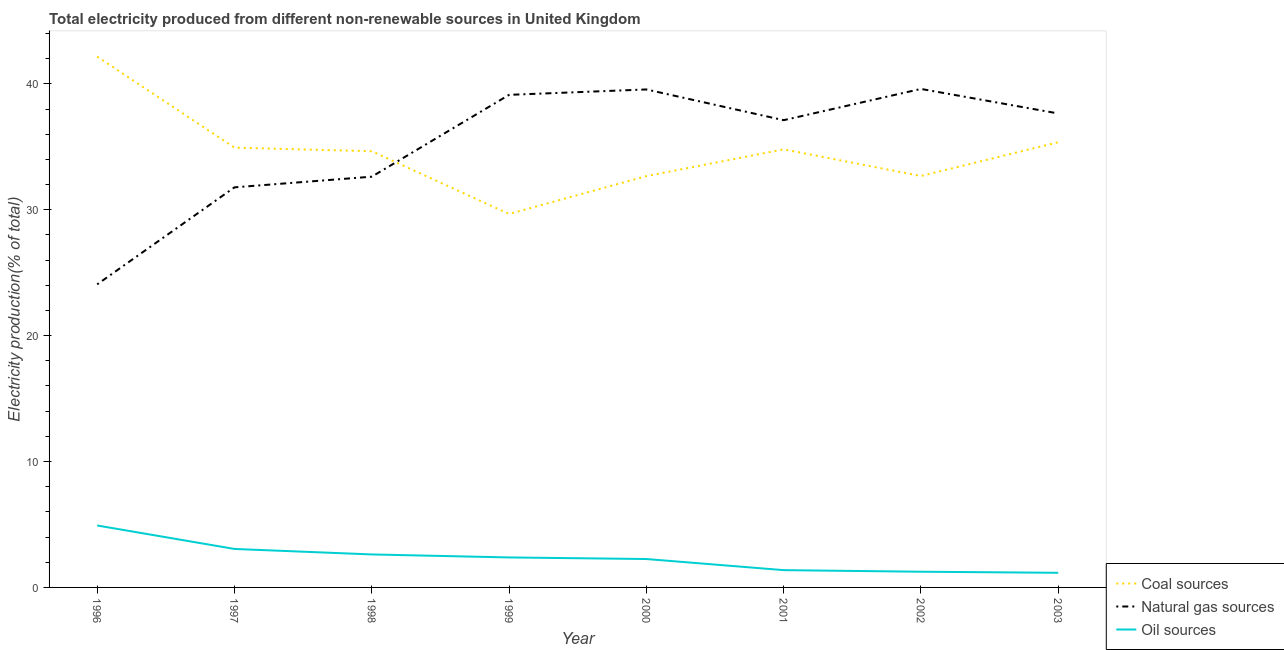Does the line corresponding to percentage of electricity produced by coal intersect with the line corresponding to percentage of electricity produced by oil sources?
Make the answer very short. No. Is the number of lines equal to the number of legend labels?
Give a very brief answer. Yes. What is the percentage of electricity produced by coal in 2003?
Make the answer very short. 35.36. Across all years, what is the maximum percentage of electricity produced by coal?
Ensure brevity in your answer.  42.16. Across all years, what is the minimum percentage of electricity produced by oil sources?
Offer a very short reply. 1.16. In which year was the percentage of electricity produced by oil sources minimum?
Give a very brief answer. 2003. What is the total percentage of electricity produced by natural gas in the graph?
Provide a succinct answer. 281.5. What is the difference between the percentage of electricity produced by natural gas in 2000 and that in 2003?
Provide a succinct answer. 1.91. What is the difference between the percentage of electricity produced by oil sources in 1998 and the percentage of electricity produced by natural gas in 2003?
Provide a short and direct response. -35.03. What is the average percentage of electricity produced by natural gas per year?
Offer a very short reply. 35.19. In the year 1997, what is the difference between the percentage of electricity produced by natural gas and percentage of electricity produced by coal?
Provide a short and direct response. -3.15. What is the ratio of the percentage of electricity produced by coal in 1996 to that in 1997?
Ensure brevity in your answer.  1.21. Is the percentage of electricity produced by coal in 1996 less than that in 2001?
Provide a succinct answer. No. What is the difference between the highest and the second highest percentage of electricity produced by oil sources?
Make the answer very short. 1.86. What is the difference between the highest and the lowest percentage of electricity produced by natural gas?
Your response must be concise. 15.52. In how many years, is the percentage of electricity produced by coal greater than the average percentage of electricity produced by coal taken over all years?
Your response must be concise. 5. Is the sum of the percentage of electricity produced by oil sources in 2000 and 2003 greater than the maximum percentage of electricity produced by natural gas across all years?
Your response must be concise. No. Does the percentage of electricity produced by natural gas monotonically increase over the years?
Offer a terse response. No. Is the percentage of electricity produced by coal strictly greater than the percentage of electricity produced by oil sources over the years?
Your answer should be compact. Yes. How many years are there in the graph?
Offer a terse response. 8. What is the difference between two consecutive major ticks on the Y-axis?
Keep it short and to the point. 10. How many legend labels are there?
Your answer should be very brief. 3. How are the legend labels stacked?
Provide a short and direct response. Vertical. What is the title of the graph?
Your answer should be compact. Total electricity produced from different non-renewable sources in United Kingdom. Does "Ages 50+" appear as one of the legend labels in the graph?
Your answer should be compact. No. What is the label or title of the X-axis?
Your answer should be compact. Year. What is the label or title of the Y-axis?
Your answer should be compact. Electricity production(% of total). What is the Electricity production(% of total) of Coal sources in 1996?
Make the answer very short. 42.16. What is the Electricity production(% of total) in Natural gas sources in 1996?
Your response must be concise. 24.07. What is the Electricity production(% of total) of Oil sources in 1996?
Keep it short and to the point. 4.92. What is the Electricity production(% of total) in Coal sources in 1997?
Your response must be concise. 34.93. What is the Electricity production(% of total) of Natural gas sources in 1997?
Ensure brevity in your answer.  31.78. What is the Electricity production(% of total) of Oil sources in 1997?
Keep it short and to the point. 3.06. What is the Electricity production(% of total) of Coal sources in 1998?
Make the answer very short. 34.65. What is the Electricity production(% of total) of Natural gas sources in 1998?
Give a very brief answer. 32.62. What is the Electricity production(% of total) in Oil sources in 1998?
Your response must be concise. 2.62. What is the Electricity production(% of total) in Coal sources in 1999?
Ensure brevity in your answer.  29.66. What is the Electricity production(% of total) of Natural gas sources in 1999?
Your answer should be very brief. 39.12. What is the Electricity production(% of total) in Oil sources in 1999?
Provide a succinct answer. 2.38. What is the Electricity production(% of total) in Coal sources in 2000?
Ensure brevity in your answer.  32.67. What is the Electricity production(% of total) of Natural gas sources in 2000?
Your answer should be compact. 39.55. What is the Electricity production(% of total) of Oil sources in 2000?
Offer a very short reply. 2.26. What is the Electricity production(% of total) of Coal sources in 2001?
Give a very brief answer. 34.8. What is the Electricity production(% of total) of Natural gas sources in 2001?
Offer a terse response. 37.11. What is the Electricity production(% of total) of Oil sources in 2001?
Give a very brief answer. 1.37. What is the Electricity production(% of total) of Coal sources in 2002?
Ensure brevity in your answer.  32.68. What is the Electricity production(% of total) of Natural gas sources in 2002?
Offer a very short reply. 39.59. What is the Electricity production(% of total) of Oil sources in 2002?
Make the answer very short. 1.25. What is the Electricity production(% of total) in Coal sources in 2003?
Make the answer very short. 35.36. What is the Electricity production(% of total) in Natural gas sources in 2003?
Offer a very short reply. 37.65. What is the Electricity production(% of total) of Oil sources in 2003?
Your response must be concise. 1.16. Across all years, what is the maximum Electricity production(% of total) of Coal sources?
Provide a short and direct response. 42.16. Across all years, what is the maximum Electricity production(% of total) in Natural gas sources?
Provide a succinct answer. 39.59. Across all years, what is the maximum Electricity production(% of total) of Oil sources?
Your answer should be very brief. 4.92. Across all years, what is the minimum Electricity production(% of total) of Coal sources?
Offer a very short reply. 29.66. Across all years, what is the minimum Electricity production(% of total) in Natural gas sources?
Your answer should be compact. 24.07. Across all years, what is the minimum Electricity production(% of total) of Oil sources?
Your answer should be compact. 1.16. What is the total Electricity production(% of total) of Coal sources in the graph?
Give a very brief answer. 276.9. What is the total Electricity production(% of total) of Natural gas sources in the graph?
Keep it short and to the point. 281.5. What is the total Electricity production(% of total) of Oil sources in the graph?
Keep it short and to the point. 19.02. What is the difference between the Electricity production(% of total) of Coal sources in 1996 and that in 1997?
Offer a very short reply. 7.23. What is the difference between the Electricity production(% of total) of Natural gas sources in 1996 and that in 1997?
Your response must be concise. -7.71. What is the difference between the Electricity production(% of total) in Oil sources in 1996 and that in 1997?
Your response must be concise. 1.86. What is the difference between the Electricity production(% of total) of Coal sources in 1996 and that in 1998?
Offer a very short reply. 7.51. What is the difference between the Electricity production(% of total) of Natural gas sources in 1996 and that in 1998?
Your answer should be very brief. -8.55. What is the difference between the Electricity production(% of total) of Oil sources in 1996 and that in 1998?
Your answer should be compact. 2.3. What is the difference between the Electricity production(% of total) of Coal sources in 1996 and that in 1999?
Provide a succinct answer. 12.5. What is the difference between the Electricity production(% of total) of Natural gas sources in 1996 and that in 1999?
Offer a terse response. -15.05. What is the difference between the Electricity production(% of total) in Oil sources in 1996 and that in 1999?
Offer a very short reply. 2.54. What is the difference between the Electricity production(% of total) in Coal sources in 1996 and that in 2000?
Ensure brevity in your answer.  9.49. What is the difference between the Electricity production(% of total) in Natural gas sources in 1996 and that in 2000?
Offer a very short reply. -15.48. What is the difference between the Electricity production(% of total) in Oil sources in 1996 and that in 2000?
Ensure brevity in your answer.  2.66. What is the difference between the Electricity production(% of total) in Coal sources in 1996 and that in 2001?
Ensure brevity in your answer.  7.36. What is the difference between the Electricity production(% of total) of Natural gas sources in 1996 and that in 2001?
Provide a succinct answer. -13.04. What is the difference between the Electricity production(% of total) of Oil sources in 1996 and that in 2001?
Make the answer very short. 3.55. What is the difference between the Electricity production(% of total) in Coal sources in 1996 and that in 2002?
Make the answer very short. 9.48. What is the difference between the Electricity production(% of total) in Natural gas sources in 1996 and that in 2002?
Keep it short and to the point. -15.52. What is the difference between the Electricity production(% of total) of Oil sources in 1996 and that in 2002?
Provide a succinct answer. 3.67. What is the difference between the Electricity production(% of total) in Coal sources in 1996 and that in 2003?
Provide a succinct answer. 6.8. What is the difference between the Electricity production(% of total) of Natural gas sources in 1996 and that in 2003?
Ensure brevity in your answer.  -13.57. What is the difference between the Electricity production(% of total) in Oil sources in 1996 and that in 2003?
Offer a terse response. 3.76. What is the difference between the Electricity production(% of total) in Coal sources in 1997 and that in 1998?
Your response must be concise. 0.28. What is the difference between the Electricity production(% of total) in Natural gas sources in 1997 and that in 1998?
Your answer should be very brief. -0.85. What is the difference between the Electricity production(% of total) in Oil sources in 1997 and that in 1998?
Your response must be concise. 0.44. What is the difference between the Electricity production(% of total) in Coal sources in 1997 and that in 1999?
Ensure brevity in your answer.  5.27. What is the difference between the Electricity production(% of total) of Natural gas sources in 1997 and that in 1999?
Give a very brief answer. -7.35. What is the difference between the Electricity production(% of total) in Oil sources in 1997 and that in 1999?
Offer a very short reply. 0.67. What is the difference between the Electricity production(% of total) in Coal sources in 1997 and that in 2000?
Your answer should be compact. 2.26. What is the difference between the Electricity production(% of total) in Natural gas sources in 1997 and that in 2000?
Provide a short and direct response. -7.78. What is the difference between the Electricity production(% of total) in Oil sources in 1997 and that in 2000?
Keep it short and to the point. 0.8. What is the difference between the Electricity production(% of total) of Coal sources in 1997 and that in 2001?
Give a very brief answer. 0.14. What is the difference between the Electricity production(% of total) in Natural gas sources in 1997 and that in 2001?
Give a very brief answer. -5.33. What is the difference between the Electricity production(% of total) in Oil sources in 1997 and that in 2001?
Offer a terse response. 1.68. What is the difference between the Electricity production(% of total) of Coal sources in 1997 and that in 2002?
Provide a short and direct response. 2.25. What is the difference between the Electricity production(% of total) in Natural gas sources in 1997 and that in 2002?
Your answer should be very brief. -7.82. What is the difference between the Electricity production(% of total) of Oil sources in 1997 and that in 2002?
Your answer should be compact. 1.81. What is the difference between the Electricity production(% of total) in Coal sources in 1997 and that in 2003?
Make the answer very short. -0.43. What is the difference between the Electricity production(% of total) in Natural gas sources in 1997 and that in 2003?
Offer a terse response. -5.87. What is the difference between the Electricity production(% of total) of Oil sources in 1997 and that in 2003?
Your answer should be compact. 1.89. What is the difference between the Electricity production(% of total) in Coal sources in 1998 and that in 1999?
Make the answer very short. 4.98. What is the difference between the Electricity production(% of total) of Natural gas sources in 1998 and that in 1999?
Your answer should be very brief. -6.5. What is the difference between the Electricity production(% of total) in Oil sources in 1998 and that in 1999?
Your answer should be compact. 0.24. What is the difference between the Electricity production(% of total) in Coal sources in 1998 and that in 2000?
Provide a succinct answer. 1.98. What is the difference between the Electricity production(% of total) of Natural gas sources in 1998 and that in 2000?
Ensure brevity in your answer.  -6.93. What is the difference between the Electricity production(% of total) of Oil sources in 1998 and that in 2000?
Make the answer very short. 0.36. What is the difference between the Electricity production(% of total) in Coal sources in 1998 and that in 2001?
Your answer should be very brief. -0.15. What is the difference between the Electricity production(% of total) of Natural gas sources in 1998 and that in 2001?
Offer a terse response. -4.49. What is the difference between the Electricity production(% of total) of Oil sources in 1998 and that in 2001?
Keep it short and to the point. 1.25. What is the difference between the Electricity production(% of total) of Coal sources in 1998 and that in 2002?
Your answer should be compact. 1.97. What is the difference between the Electricity production(% of total) in Natural gas sources in 1998 and that in 2002?
Provide a short and direct response. -6.97. What is the difference between the Electricity production(% of total) in Oil sources in 1998 and that in 2002?
Your answer should be compact. 1.37. What is the difference between the Electricity production(% of total) of Coal sources in 1998 and that in 2003?
Your answer should be very brief. -0.71. What is the difference between the Electricity production(% of total) of Natural gas sources in 1998 and that in 2003?
Your answer should be compact. -5.02. What is the difference between the Electricity production(% of total) of Oil sources in 1998 and that in 2003?
Your answer should be compact. 1.46. What is the difference between the Electricity production(% of total) of Coal sources in 1999 and that in 2000?
Keep it short and to the point. -3.01. What is the difference between the Electricity production(% of total) of Natural gas sources in 1999 and that in 2000?
Keep it short and to the point. -0.43. What is the difference between the Electricity production(% of total) of Oil sources in 1999 and that in 2000?
Provide a short and direct response. 0.13. What is the difference between the Electricity production(% of total) of Coal sources in 1999 and that in 2001?
Provide a succinct answer. -5.13. What is the difference between the Electricity production(% of total) in Natural gas sources in 1999 and that in 2001?
Offer a very short reply. 2.01. What is the difference between the Electricity production(% of total) of Oil sources in 1999 and that in 2001?
Make the answer very short. 1.01. What is the difference between the Electricity production(% of total) in Coal sources in 1999 and that in 2002?
Your response must be concise. -3.02. What is the difference between the Electricity production(% of total) of Natural gas sources in 1999 and that in 2002?
Keep it short and to the point. -0.47. What is the difference between the Electricity production(% of total) in Oil sources in 1999 and that in 2002?
Give a very brief answer. 1.13. What is the difference between the Electricity production(% of total) of Coal sources in 1999 and that in 2003?
Keep it short and to the point. -5.7. What is the difference between the Electricity production(% of total) of Natural gas sources in 1999 and that in 2003?
Your response must be concise. 1.48. What is the difference between the Electricity production(% of total) in Oil sources in 1999 and that in 2003?
Give a very brief answer. 1.22. What is the difference between the Electricity production(% of total) of Coal sources in 2000 and that in 2001?
Your answer should be very brief. -2.13. What is the difference between the Electricity production(% of total) in Natural gas sources in 2000 and that in 2001?
Make the answer very short. 2.44. What is the difference between the Electricity production(% of total) of Oil sources in 2000 and that in 2001?
Your answer should be compact. 0.88. What is the difference between the Electricity production(% of total) in Coal sources in 2000 and that in 2002?
Give a very brief answer. -0.01. What is the difference between the Electricity production(% of total) in Natural gas sources in 2000 and that in 2002?
Give a very brief answer. -0.04. What is the difference between the Electricity production(% of total) of Oil sources in 2000 and that in 2002?
Make the answer very short. 1.01. What is the difference between the Electricity production(% of total) in Coal sources in 2000 and that in 2003?
Provide a short and direct response. -2.69. What is the difference between the Electricity production(% of total) of Natural gas sources in 2000 and that in 2003?
Provide a succinct answer. 1.91. What is the difference between the Electricity production(% of total) of Oil sources in 2000 and that in 2003?
Your response must be concise. 1.09. What is the difference between the Electricity production(% of total) in Coal sources in 2001 and that in 2002?
Your response must be concise. 2.12. What is the difference between the Electricity production(% of total) of Natural gas sources in 2001 and that in 2002?
Ensure brevity in your answer.  -2.48. What is the difference between the Electricity production(% of total) in Oil sources in 2001 and that in 2002?
Keep it short and to the point. 0.13. What is the difference between the Electricity production(% of total) in Coal sources in 2001 and that in 2003?
Provide a short and direct response. -0.56. What is the difference between the Electricity production(% of total) of Natural gas sources in 2001 and that in 2003?
Your answer should be compact. -0.53. What is the difference between the Electricity production(% of total) in Oil sources in 2001 and that in 2003?
Make the answer very short. 0.21. What is the difference between the Electricity production(% of total) in Coal sources in 2002 and that in 2003?
Give a very brief answer. -2.68. What is the difference between the Electricity production(% of total) in Natural gas sources in 2002 and that in 2003?
Provide a succinct answer. 1.95. What is the difference between the Electricity production(% of total) of Oil sources in 2002 and that in 2003?
Your response must be concise. 0.09. What is the difference between the Electricity production(% of total) of Coal sources in 1996 and the Electricity production(% of total) of Natural gas sources in 1997?
Your response must be concise. 10.38. What is the difference between the Electricity production(% of total) in Coal sources in 1996 and the Electricity production(% of total) in Oil sources in 1997?
Your answer should be very brief. 39.1. What is the difference between the Electricity production(% of total) of Natural gas sources in 1996 and the Electricity production(% of total) of Oil sources in 1997?
Make the answer very short. 21.02. What is the difference between the Electricity production(% of total) in Coal sources in 1996 and the Electricity production(% of total) in Natural gas sources in 1998?
Your answer should be compact. 9.54. What is the difference between the Electricity production(% of total) of Coal sources in 1996 and the Electricity production(% of total) of Oil sources in 1998?
Give a very brief answer. 39.54. What is the difference between the Electricity production(% of total) in Natural gas sources in 1996 and the Electricity production(% of total) in Oil sources in 1998?
Provide a short and direct response. 21.45. What is the difference between the Electricity production(% of total) of Coal sources in 1996 and the Electricity production(% of total) of Natural gas sources in 1999?
Give a very brief answer. 3.04. What is the difference between the Electricity production(% of total) in Coal sources in 1996 and the Electricity production(% of total) in Oil sources in 1999?
Offer a very short reply. 39.78. What is the difference between the Electricity production(% of total) of Natural gas sources in 1996 and the Electricity production(% of total) of Oil sources in 1999?
Offer a terse response. 21.69. What is the difference between the Electricity production(% of total) of Coal sources in 1996 and the Electricity production(% of total) of Natural gas sources in 2000?
Keep it short and to the point. 2.61. What is the difference between the Electricity production(% of total) in Coal sources in 1996 and the Electricity production(% of total) in Oil sources in 2000?
Offer a very short reply. 39.9. What is the difference between the Electricity production(% of total) in Natural gas sources in 1996 and the Electricity production(% of total) in Oil sources in 2000?
Offer a very short reply. 21.82. What is the difference between the Electricity production(% of total) of Coal sources in 1996 and the Electricity production(% of total) of Natural gas sources in 2001?
Your answer should be compact. 5.05. What is the difference between the Electricity production(% of total) in Coal sources in 1996 and the Electricity production(% of total) in Oil sources in 2001?
Your response must be concise. 40.79. What is the difference between the Electricity production(% of total) of Natural gas sources in 1996 and the Electricity production(% of total) of Oil sources in 2001?
Keep it short and to the point. 22.7. What is the difference between the Electricity production(% of total) of Coal sources in 1996 and the Electricity production(% of total) of Natural gas sources in 2002?
Offer a terse response. 2.57. What is the difference between the Electricity production(% of total) in Coal sources in 1996 and the Electricity production(% of total) in Oil sources in 2002?
Your answer should be very brief. 40.91. What is the difference between the Electricity production(% of total) of Natural gas sources in 1996 and the Electricity production(% of total) of Oil sources in 2002?
Your answer should be very brief. 22.82. What is the difference between the Electricity production(% of total) of Coal sources in 1996 and the Electricity production(% of total) of Natural gas sources in 2003?
Your answer should be very brief. 4.51. What is the difference between the Electricity production(% of total) of Coal sources in 1996 and the Electricity production(% of total) of Oil sources in 2003?
Offer a very short reply. 41. What is the difference between the Electricity production(% of total) in Natural gas sources in 1996 and the Electricity production(% of total) in Oil sources in 2003?
Keep it short and to the point. 22.91. What is the difference between the Electricity production(% of total) in Coal sources in 1997 and the Electricity production(% of total) in Natural gas sources in 1998?
Offer a terse response. 2.31. What is the difference between the Electricity production(% of total) in Coal sources in 1997 and the Electricity production(% of total) in Oil sources in 1998?
Ensure brevity in your answer.  32.31. What is the difference between the Electricity production(% of total) in Natural gas sources in 1997 and the Electricity production(% of total) in Oil sources in 1998?
Offer a very short reply. 29.16. What is the difference between the Electricity production(% of total) in Coal sources in 1997 and the Electricity production(% of total) in Natural gas sources in 1999?
Your answer should be compact. -4.19. What is the difference between the Electricity production(% of total) in Coal sources in 1997 and the Electricity production(% of total) in Oil sources in 1999?
Your answer should be compact. 32.55. What is the difference between the Electricity production(% of total) of Natural gas sources in 1997 and the Electricity production(% of total) of Oil sources in 1999?
Give a very brief answer. 29.4. What is the difference between the Electricity production(% of total) of Coal sources in 1997 and the Electricity production(% of total) of Natural gas sources in 2000?
Provide a succinct answer. -4.62. What is the difference between the Electricity production(% of total) of Coal sources in 1997 and the Electricity production(% of total) of Oil sources in 2000?
Keep it short and to the point. 32.68. What is the difference between the Electricity production(% of total) in Natural gas sources in 1997 and the Electricity production(% of total) in Oil sources in 2000?
Your response must be concise. 29.52. What is the difference between the Electricity production(% of total) of Coal sources in 1997 and the Electricity production(% of total) of Natural gas sources in 2001?
Your response must be concise. -2.18. What is the difference between the Electricity production(% of total) of Coal sources in 1997 and the Electricity production(% of total) of Oil sources in 2001?
Ensure brevity in your answer.  33.56. What is the difference between the Electricity production(% of total) of Natural gas sources in 1997 and the Electricity production(% of total) of Oil sources in 2001?
Ensure brevity in your answer.  30.4. What is the difference between the Electricity production(% of total) in Coal sources in 1997 and the Electricity production(% of total) in Natural gas sources in 2002?
Offer a terse response. -4.66. What is the difference between the Electricity production(% of total) in Coal sources in 1997 and the Electricity production(% of total) in Oil sources in 2002?
Your answer should be compact. 33.68. What is the difference between the Electricity production(% of total) in Natural gas sources in 1997 and the Electricity production(% of total) in Oil sources in 2002?
Provide a short and direct response. 30.53. What is the difference between the Electricity production(% of total) of Coal sources in 1997 and the Electricity production(% of total) of Natural gas sources in 2003?
Give a very brief answer. -2.71. What is the difference between the Electricity production(% of total) in Coal sources in 1997 and the Electricity production(% of total) in Oil sources in 2003?
Your response must be concise. 33.77. What is the difference between the Electricity production(% of total) in Natural gas sources in 1997 and the Electricity production(% of total) in Oil sources in 2003?
Your answer should be compact. 30.62. What is the difference between the Electricity production(% of total) of Coal sources in 1998 and the Electricity production(% of total) of Natural gas sources in 1999?
Make the answer very short. -4.48. What is the difference between the Electricity production(% of total) in Coal sources in 1998 and the Electricity production(% of total) in Oil sources in 1999?
Keep it short and to the point. 32.26. What is the difference between the Electricity production(% of total) of Natural gas sources in 1998 and the Electricity production(% of total) of Oil sources in 1999?
Give a very brief answer. 30.24. What is the difference between the Electricity production(% of total) in Coal sources in 1998 and the Electricity production(% of total) in Natural gas sources in 2000?
Make the answer very short. -4.91. What is the difference between the Electricity production(% of total) in Coal sources in 1998 and the Electricity production(% of total) in Oil sources in 2000?
Offer a very short reply. 32.39. What is the difference between the Electricity production(% of total) in Natural gas sources in 1998 and the Electricity production(% of total) in Oil sources in 2000?
Your answer should be very brief. 30.37. What is the difference between the Electricity production(% of total) in Coal sources in 1998 and the Electricity production(% of total) in Natural gas sources in 2001?
Provide a short and direct response. -2.47. What is the difference between the Electricity production(% of total) in Coal sources in 1998 and the Electricity production(% of total) in Oil sources in 2001?
Your response must be concise. 33.27. What is the difference between the Electricity production(% of total) of Natural gas sources in 1998 and the Electricity production(% of total) of Oil sources in 2001?
Offer a very short reply. 31.25. What is the difference between the Electricity production(% of total) in Coal sources in 1998 and the Electricity production(% of total) in Natural gas sources in 2002?
Your answer should be very brief. -4.95. What is the difference between the Electricity production(% of total) in Coal sources in 1998 and the Electricity production(% of total) in Oil sources in 2002?
Your response must be concise. 33.4. What is the difference between the Electricity production(% of total) of Natural gas sources in 1998 and the Electricity production(% of total) of Oil sources in 2002?
Offer a very short reply. 31.38. What is the difference between the Electricity production(% of total) in Coal sources in 1998 and the Electricity production(% of total) in Natural gas sources in 2003?
Provide a short and direct response. -3. What is the difference between the Electricity production(% of total) in Coal sources in 1998 and the Electricity production(% of total) in Oil sources in 2003?
Keep it short and to the point. 33.48. What is the difference between the Electricity production(% of total) of Natural gas sources in 1998 and the Electricity production(% of total) of Oil sources in 2003?
Your answer should be very brief. 31.46. What is the difference between the Electricity production(% of total) in Coal sources in 1999 and the Electricity production(% of total) in Natural gas sources in 2000?
Offer a very short reply. -9.89. What is the difference between the Electricity production(% of total) in Coal sources in 1999 and the Electricity production(% of total) in Oil sources in 2000?
Provide a short and direct response. 27.41. What is the difference between the Electricity production(% of total) of Natural gas sources in 1999 and the Electricity production(% of total) of Oil sources in 2000?
Your answer should be compact. 36.87. What is the difference between the Electricity production(% of total) in Coal sources in 1999 and the Electricity production(% of total) in Natural gas sources in 2001?
Provide a succinct answer. -7.45. What is the difference between the Electricity production(% of total) in Coal sources in 1999 and the Electricity production(% of total) in Oil sources in 2001?
Keep it short and to the point. 28.29. What is the difference between the Electricity production(% of total) in Natural gas sources in 1999 and the Electricity production(% of total) in Oil sources in 2001?
Make the answer very short. 37.75. What is the difference between the Electricity production(% of total) in Coal sources in 1999 and the Electricity production(% of total) in Natural gas sources in 2002?
Provide a short and direct response. -9.93. What is the difference between the Electricity production(% of total) in Coal sources in 1999 and the Electricity production(% of total) in Oil sources in 2002?
Your answer should be very brief. 28.41. What is the difference between the Electricity production(% of total) of Natural gas sources in 1999 and the Electricity production(% of total) of Oil sources in 2002?
Your answer should be compact. 37.88. What is the difference between the Electricity production(% of total) of Coal sources in 1999 and the Electricity production(% of total) of Natural gas sources in 2003?
Offer a very short reply. -7.98. What is the difference between the Electricity production(% of total) of Coal sources in 1999 and the Electricity production(% of total) of Oil sources in 2003?
Your response must be concise. 28.5. What is the difference between the Electricity production(% of total) of Natural gas sources in 1999 and the Electricity production(% of total) of Oil sources in 2003?
Your answer should be compact. 37.96. What is the difference between the Electricity production(% of total) in Coal sources in 2000 and the Electricity production(% of total) in Natural gas sources in 2001?
Your answer should be very brief. -4.44. What is the difference between the Electricity production(% of total) in Coal sources in 2000 and the Electricity production(% of total) in Oil sources in 2001?
Offer a terse response. 31.29. What is the difference between the Electricity production(% of total) in Natural gas sources in 2000 and the Electricity production(% of total) in Oil sources in 2001?
Offer a terse response. 38.18. What is the difference between the Electricity production(% of total) of Coal sources in 2000 and the Electricity production(% of total) of Natural gas sources in 2002?
Make the answer very short. -6.93. What is the difference between the Electricity production(% of total) of Coal sources in 2000 and the Electricity production(% of total) of Oil sources in 2002?
Make the answer very short. 31.42. What is the difference between the Electricity production(% of total) in Natural gas sources in 2000 and the Electricity production(% of total) in Oil sources in 2002?
Your answer should be very brief. 38.31. What is the difference between the Electricity production(% of total) in Coal sources in 2000 and the Electricity production(% of total) in Natural gas sources in 2003?
Keep it short and to the point. -4.98. What is the difference between the Electricity production(% of total) in Coal sources in 2000 and the Electricity production(% of total) in Oil sources in 2003?
Give a very brief answer. 31.51. What is the difference between the Electricity production(% of total) of Natural gas sources in 2000 and the Electricity production(% of total) of Oil sources in 2003?
Keep it short and to the point. 38.39. What is the difference between the Electricity production(% of total) in Coal sources in 2001 and the Electricity production(% of total) in Natural gas sources in 2002?
Offer a very short reply. -4.8. What is the difference between the Electricity production(% of total) in Coal sources in 2001 and the Electricity production(% of total) in Oil sources in 2002?
Ensure brevity in your answer.  33.55. What is the difference between the Electricity production(% of total) in Natural gas sources in 2001 and the Electricity production(% of total) in Oil sources in 2002?
Give a very brief answer. 35.86. What is the difference between the Electricity production(% of total) in Coal sources in 2001 and the Electricity production(% of total) in Natural gas sources in 2003?
Offer a very short reply. -2.85. What is the difference between the Electricity production(% of total) in Coal sources in 2001 and the Electricity production(% of total) in Oil sources in 2003?
Provide a short and direct response. 33.63. What is the difference between the Electricity production(% of total) in Natural gas sources in 2001 and the Electricity production(% of total) in Oil sources in 2003?
Your answer should be very brief. 35.95. What is the difference between the Electricity production(% of total) of Coal sources in 2002 and the Electricity production(% of total) of Natural gas sources in 2003?
Keep it short and to the point. -4.97. What is the difference between the Electricity production(% of total) of Coal sources in 2002 and the Electricity production(% of total) of Oil sources in 2003?
Your answer should be very brief. 31.52. What is the difference between the Electricity production(% of total) in Natural gas sources in 2002 and the Electricity production(% of total) in Oil sources in 2003?
Give a very brief answer. 38.43. What is the average Electricity production(% of total) of Coal sources per year?
Offer a terse response. 34.61. What is the average Electricity production(% of total) of Natural gas sources per year?
Provide a short and direct response. 35.19. What is the average Electricity production(% of total) of Oil sources per year?
Your answer should be very brief. 2.38. In the year 1996, what is the difference between the Electricity production(% of total) in Coal sources and Electricity production(% of total) in Natural gas sources?
Offer a very short reply. 18.09. In the year 1996, what is the difference between the Electricity production(% of total) of Coal sources and Electricity production(% of total) of Oil sources?
Make the answer very short. 37.24. In the year 1996, what is the difference between the Electricity production(% of total) in Natural gas sources and Electricity production(% of total) in Oil sources?
Offer a very short reply. 19.15. In the year 1997, what is the difference between the Electricity production(% of total) of Coal sources and Electricity production(% of total) of Natural gas sources?
Your response must be concise. 3.15. In the year 1997, what is the difference between the Electricity production(% of total) in Coal sources and Electricity production(% of total) in Oil sources?
Keep it short and to the point. 31.88. In the year 1997, what is the difference between the Electricity production(% of total) of Natural gas sources and Electricity production(% of total) of Oil sources?
Make the answer very short. 28.72. In the year 1998, what is the difference between the Electricity production(% of total) of Coal sources and Electricity production(% of total) of Natural gas sources?
Offer a terse response. 2.02. In the year 1998, what is the difference between the Electricity production(% of total) in Coal sources and Electricity production(% of total) in Oil sources?
Make the answer very short. 32.03. In the year 1998, what is the difference between the Electricity production(% of total) of Natural gas sources and Electricity production(% of total) of Oil sources?
Your response must be concise. 30. In the year 1999, what is the difference between the Electricity production(% of total) of Coal sources and Electricity production(% of total) of Natural gas sources?
Your response must be concise. -9.46. In the year 1999, what is the difference between the Electricity production(% of total) of Coal sources and Electricity production(% of total) of Oil sources?
Offer a very short reply. 27.28. In the year 1999, what is the difference between the Electricity production(% of total) in Natural gas sources and Electricity production(% of total) in Oil sources?
Offer a terse response. 36.74. In the year 2000, what is the difference between the Electricity production(% of total) of Coal sources and Electricity production(% of total) of Natural gas sources?
Make the answer very short. -6.89. In the year 2000, what is the difference between the Electricity production(% of total) in Coal sources and Electricity production(% of total) in Oil sources?
Provide a succinct answer. 30.41. In the year 2000, what is the difference between the Electricity production(% of total) of Natural gas sources and Electricity production(% of total) of Oil sources?
Keep it short and to the point. 37.3. In the year 2001, what is the difference between the Electricity production(% of total) in Coal sources and Electricity production(% of total) in Natural gas sources?
Ensure brevity in your answer.  -2.32. In the year 2001, what is the difference between the Electricity production(% of total) of Coal sources and Electricity production(% of total) of Oil sources?
Your answer should be compact. 33.42. In the year 2001, what is the difference between the Electricity production(% of total) in Natural gas sources and Electricity production(% of total) in Oil sources?
Offer a terse response. 35.74. In the year 2002, what is the difference between the Electricity production(% of total) of Coal sources and Electricity production(% of total) of Natural gas sources?
Your answer should be very brief. -6.92. In the year 2002, what is the difference between the Electricity production(% of total) of Coal sources and Electricity production(% of total) of Oil sources?
Give a very brief answer. 31.43. In the year 2002, what is the difference between the Electricity production(% of total) in Natural gas sources and Electricity production(% of total) in Oil sources?
Give a very brief answer. 38.35. In the year 2003, what is the difference between the Electricity production(% of total) in Coal sources and Electricity production(% of total) in Natural gas sources?
Keep it short and to the point. -2.29. In the year 2003, what is the difference between the Electricity production(% of total) of Coal sources and Electricity production(% of total) of Oil sources?
Provide a succinct answer. 34.2. In the year 2003, what is the difference between the Electricity production(% of total) of Natural gas sources and Electricity production(% of total) of Oil sources?
Your answer should be compact. 36.48. What is the ratio of the Electricity production(% of total) in Coal sources in 1996 to that in 1997?
Your answer should be compact. 1.21. What is the ratio of the Electricity production(% of total) of Natural gas sources in 1996 to that in 1997?
Make the answer very short. 0.76. What is the ratio of the Electricity production(% of total) in Oil sources in 1996 to that in 1997?
Give a very brief answer. 1.61. What is the ratio of the Electricity production(% of total) of Coal sources in 1996 to that in 1998?
Offer a terse response. 1.22. What is the ratio of the Electricity production(% of total) of Natural gas sources in 1996 to that in 1998?
Provide a short and direct response. 0.74. What is the ratio of the Electricity production(% of total) in Oil sources in 1996 to that in 1998?
Offer a very short reply. 1.88. What is the ratio of the Electricity production(% of total) of Coal sources in 1996 to that in 1999?
Provide a succinct answer. 1.42. What is the ratio of the Electricity production(% of total) in Natural gas sources in 1996 to that in 1999?
Provide a short and direct response. 0.62. What is the ratio of the Electricity production(% of total) in Oil sources in 1996 to that in 1999?
Offer a terse response. 2.07. What is the ratio of the Electricity production(% of total) in Coal sources in 1996 to that in 2000?
Your answer should be compact. 1.29. What is the ratio of the Electricity production(% of total) in Natural gas sources in 1996 to that in 2000?
Offer a very short reply. 0.61. What is the ratio of the Electricity production(% of total) of Oil sources in 1996 to that in 2000?
Offer a very short reply. 2.18. What is the ratio of the Electricity production(% of total) of Coal sources in 1996 to that in 2001?
Offer a terse response. 1.21. What is the ratio of the Electricity production(% of total) of Natural gas sources in 1996 to that in 2001?
Ensure brevity in your answer.  0.65. What is the ratio of the Electricity production(% of total) in Oil sources in 1996 to that in 2001?
Make the answer very short. 3.58. What is the ratio of the Electricity production(% of total) in Coal sources in 1996 to that in 2002?
Your answer should be compact. 1.29. What is the ratio of the Electricity production(% of total) of Natural gas sources in 1996 to that in 2002?
Your answer should be compact. 0.61. What is the ratio of the Electricity production(% of total) in Oil sources in 1996 to that in 2002?
Provide a succinct answer. 3.94. What is the ratio of the Electricity production(% of total) of Coal sources in 1996 to that in 2003?
Your response must be concise. 1.19. What is the ratio of the Electricity production(% of total) in Natural gas sources in 1996 to that in 2003?
Your response must be concise. 0.64. What is the ratio of the Electricity production(% of total) in Oil sources in 1996 to that in 2003?
Offer a very short reply. 4.24. What is the ratio of the Electricity production(% of total) of Coal sources in 1997 to that in 1998?
Your answer should be very brief. 1.01. What is the ratio of the Electricity production(% of total) in Natural gas sources in 1997 to that in 1998?
Your response must be concise. 0.97. What is the ratio of the Electricity production(% of total) in Oil sources in 1997 to that in 1998?
Your answer should be very brief. 1.17. What is the ratio of the Electricity production(% of total) in Coal sources in 1997 to that in 1999?
Provide a short and direct response. 1.18. What is the ratio of the Electricity production(% of total) of Natural gas sources in 1997 to that in 1999?
Provide a short and direct response. 0.81. What is the ratio of the Electricity production(% of total) in Oil sources in 1997 to that in 1999?
Provide a short and direct response. 1.28. What is the ratio of the Electricity production(% of total) in Coal sources in 1997 to that in 2000?
Offer a very short reply. 1.07. What is the ratio of the Electricity production(% of total) of Natural gas sources in 1997 to that in 2000?
Make the answer very short. 0.8. What is the ratio of the Electricity production(% of total) of Oil sources in 1997 to that in 2000?
Ensure brevity in your answer.  1.35. What is the ratio of the Electricity production(% of total) in Natural gas sources in 1997 to that in 2001?
Offer a very short reply. 0.86. What is the ratio of the Electricity production(% of total) of Oil sources in 1997 to that in 2001?
Keep it short and to the point. 2.22. What is the ratio of the Electricity production(% of total) of Coal sources in 1997 to that in 2002?
Give a very brief answer. 1.07. What is the ratio of the Electricity production(% of total) of Natural gas sources in 1997 to that in 2002?
Keep it short and to the point. 0.8. What is the ratio of the Electricity production(% of total) in Oil sources in 1997 to that in 2002?
Provide a succinct answer. 2.45. What is the ratio of the Electricity production(% of total) in Coal sources in 1997 to that in 2003?
Offer a terse response. 0.99. What is the ratio of the Electricity production(% of total) in Natural gas sources in 1997 to that in 2003?
Keep it short and to the point. 0.84. What is the ratio of the Electricity production(% of total) in Oil sources in 1997 to that in 2003?
Keep it short and to the point. 2.63. What is the ratio of the Electricity production(% of total) of Coal sources in 1998 to that in 1999?
Ensure brevity in your answer.  1.17. What is the ratio of the Electricity production(% of total) of Natural gas sources in 1998 to that in 1999?
Your answer should be compact. 0.83. What is the ratio of the Electricity production(% of total) of Coal sources in 1998 to that in 2000?
Make the answer very short. 1.06. What is the ratio of the Electricity production(% of total) in Natural gas sources in 1998 to that in 2000?
Your answer should be very brief. 0.82. What is the ratio of the Electricity production(% of total) of Oil sources in 1998 to that in 2000?
Ensure brevity in your answer.  1.16. What is the ratio of the Electricity production(% of total) of Coal sources in 1998 to that in 2001?
Your answer should be very brief. 1. What is the ratio of the Electricity production(% of total) of Natural gas sources in 1998 to that in 2001?
Your answer should be compact. 0.88. What is the ratio of the Electricity production(% of total) in Oil sources in 1998 to that in 2001?
Make the answer very short. 1.91. What is the ratio of the Electricity production(% of total) of Coal sources in 1998 to that in 2002?
Your answer should be compact. 1.06. What is the ratio of the Electricity production(% of total) of Natural gas sources in 1998 to that in 2002?
Provide a short and direct response. 0.82. What is the ratio of the Electricity production(% of total) of Oil sources in 1998 to that in 2002?
Your response must be concise. 2.1. What is the ratio of the Electricity production(% of total) of Coal sources in 1998 to that in 2003?
Your response must be concise. 0.98. What is the ratio of the Electricity production(% of total) in Natural gas sources in 1998 to that in 2003?
Provide a short and direct response. 0.87. What is the ratio of the Electricity production(% of total) of Oil sources in 1998 to that in 2003?
Offer a very short reply. 2.26. What is the ratio of the Electricity production(% of total) of Coal sources in 1999 to that in 2000?
Ensure brevity in your answer.  0.91. What is the ratio of the Electricity production(% of total) in Natural gas sources in 1999 to that in 2000?
Make the answer very short. 0.99. What is the ratio of the Electricity production(% of total) of Oil sources in 1999 to that in 2000?
Your response must be concise. 1.06. What is the ratio of the Electricity production(% of total) of Coal sources in 1999 to that in 2001?
Your answer should be compact. 0.85. What is the ratio of the Electricity production(% of total) of Natural gas sources in 1999 to that in 2001?
Offer a very short reply. 1.05. What is the ratio of the Electricity production(% of total) of Oil sources in 1999 to that in 2001?
Give a very brief answer. 1.73. What is the ratio of the Electricity production(% of total) of Coal sources in 1999 to that in 2002?
Give a very brief answer. 0.91. What is the ratio of the Electricity production(% of total) in Natural gas sources in 1999 to that in 2002?
Provide a succinct answer. 0.99. What is the ratio of the Electricity production(% of total) of Oil sources in 1999 to that in 2002?
Make the answer very short. 1.91. What is the ratio of the Electricity production(% of total) of Coal sources in 1999 to that in 2003?
Your answer should be compact. 0.84. What is the ratio of the Electricity production(% of total) in Natural gas sources in 1999 to that in 2003?
Make the answer very short. 1.04. What is the ratio of the Electricity production(% of total) of Oil sources in 1999 to that in 2003?
Give a very brief answer. 2.05. What is the ratio of the Electricity production(% of total) of Coal sources in 2000 to that in 2001?
Make the answer very short. 0.94. What is the ratio of the Electricity production(% of total) of Natural gas sources in 2000 to that in 2001?
Your answer should be compact. 1.07. What is the ratio of the Electricity production(% of total) of Oil sources in 2000 to that in 2001?
Ensure brevity in your answer.  1.64. What is the ratio of the Electricity production(% of total) of Natural gas sources in 2000 to that in 2002?
Give a very brief answer. 1. What is the ratio of the Electricity production(% of total) of Oil sources in 2000 to that in 2002?
Ensure brevity in your answer.  1.81. What is the ratio of the Electricity production(% of total) in Coal sources in 2000 to that in 2003?
Provide a succinct answer. 0.92. What is the ratio of the Electricity production(% of total) in Natural gas sources in 2000 to that in 2003?
Your answer should be very brief. 1.05. What is the ratio of the Electricity production(% of total) in Oil sources in 2000 to that in 2003?
Provide a short and direct response. 1.94. What is the ratio of the Electricity production(% of total) of Coal sources in 2001 to that in 2002?
Ensure brevity in your answer.  1.06. What is the ratio of the Electricity production(% of total) of Natural gas sources in 2001 to that in 2002?
Provide a succinct answer. 0.94. What is the ratio of the Electricity production(% of total) of Oil sources in 2001 to that in 2002?
Provide a succinct answer. 1.1. What is the ratio of the Electricity production(% of total) in Coal sources in 2001 to that in 2003?
Your answer should be compact. 0.98. What is the ratio of the Electricity production(% of total) of Natural gas sources in 2001 to that in 2003?
Ensure brevity in your answer.  0.99. What is the ratio of the Electricity production(% of total) in Oil sources in 2001 to that in 2003?
Make the answer very short. 1.18. What is the ratio of the Electricity production(% of total) of Coal sources in 2002 to that in 2003?
Ensure brevity in your answer.  0.92. What is the ratio of the Electricity production(% of total) in Natural gas sources in 2002 to that in 2003?
Provide a short and direct response. 1.05. What is the ratio of the Electricity production(% of total) in Oil sources in 2002 to that in 2003?
Provide a succinct answer. 1.07. What is the difference between the highest and the second highest Electricity production(% of total) in Coal sources?
Provide a short and direct response. 6.8. What is the difference between the highest and the second highest Electricity production(% of total) in Natural gas sources?
Your answer should be compact. 0.04. What is the difference between the highest and the second highest Electricity production(% of total) of Oil sources?
Provide a succinct answer. 1.86. What is the difference between the highest and the lowest Electricity production(% of total) of Coal sources?
Offer a very short reply. 12.5. What is the difference between the highest and the lowest Electricity production(% of total) in Natural gas sources?
Keep it short and to the point. 15.52. What is the difference between the highest and the lowest Electricity production(% of total) in Oil sources?
Your answer should be compact. 3.76. 